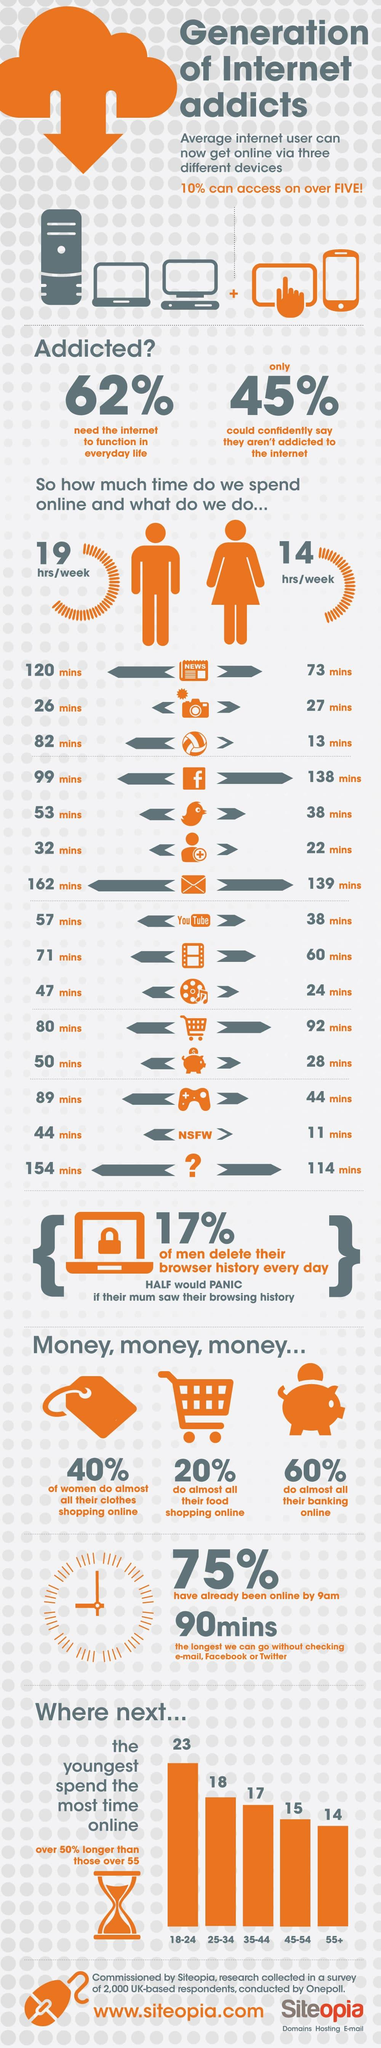Identify some key points in this picture. On average, males spend approximately 57 minutes per week on YouTube. On average, females spend approximately 14 hours per week online. On average, females in our survey spend 73 minutes per week reading news. The average male spends 99 minutes per week on Facebook. On average, females spend approximately 38 minutes per week on Twitter. 